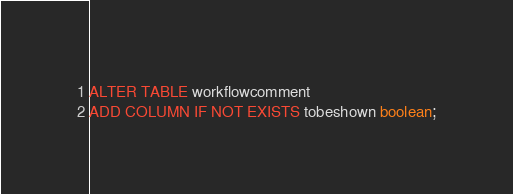<code> <loc_0><loc_0><loc_500><loc_500><_SQL_>ALTER TABLE workflowcomment
ADD COLUMN IF NOT EXISTS tobeshown boolean;
</code> 